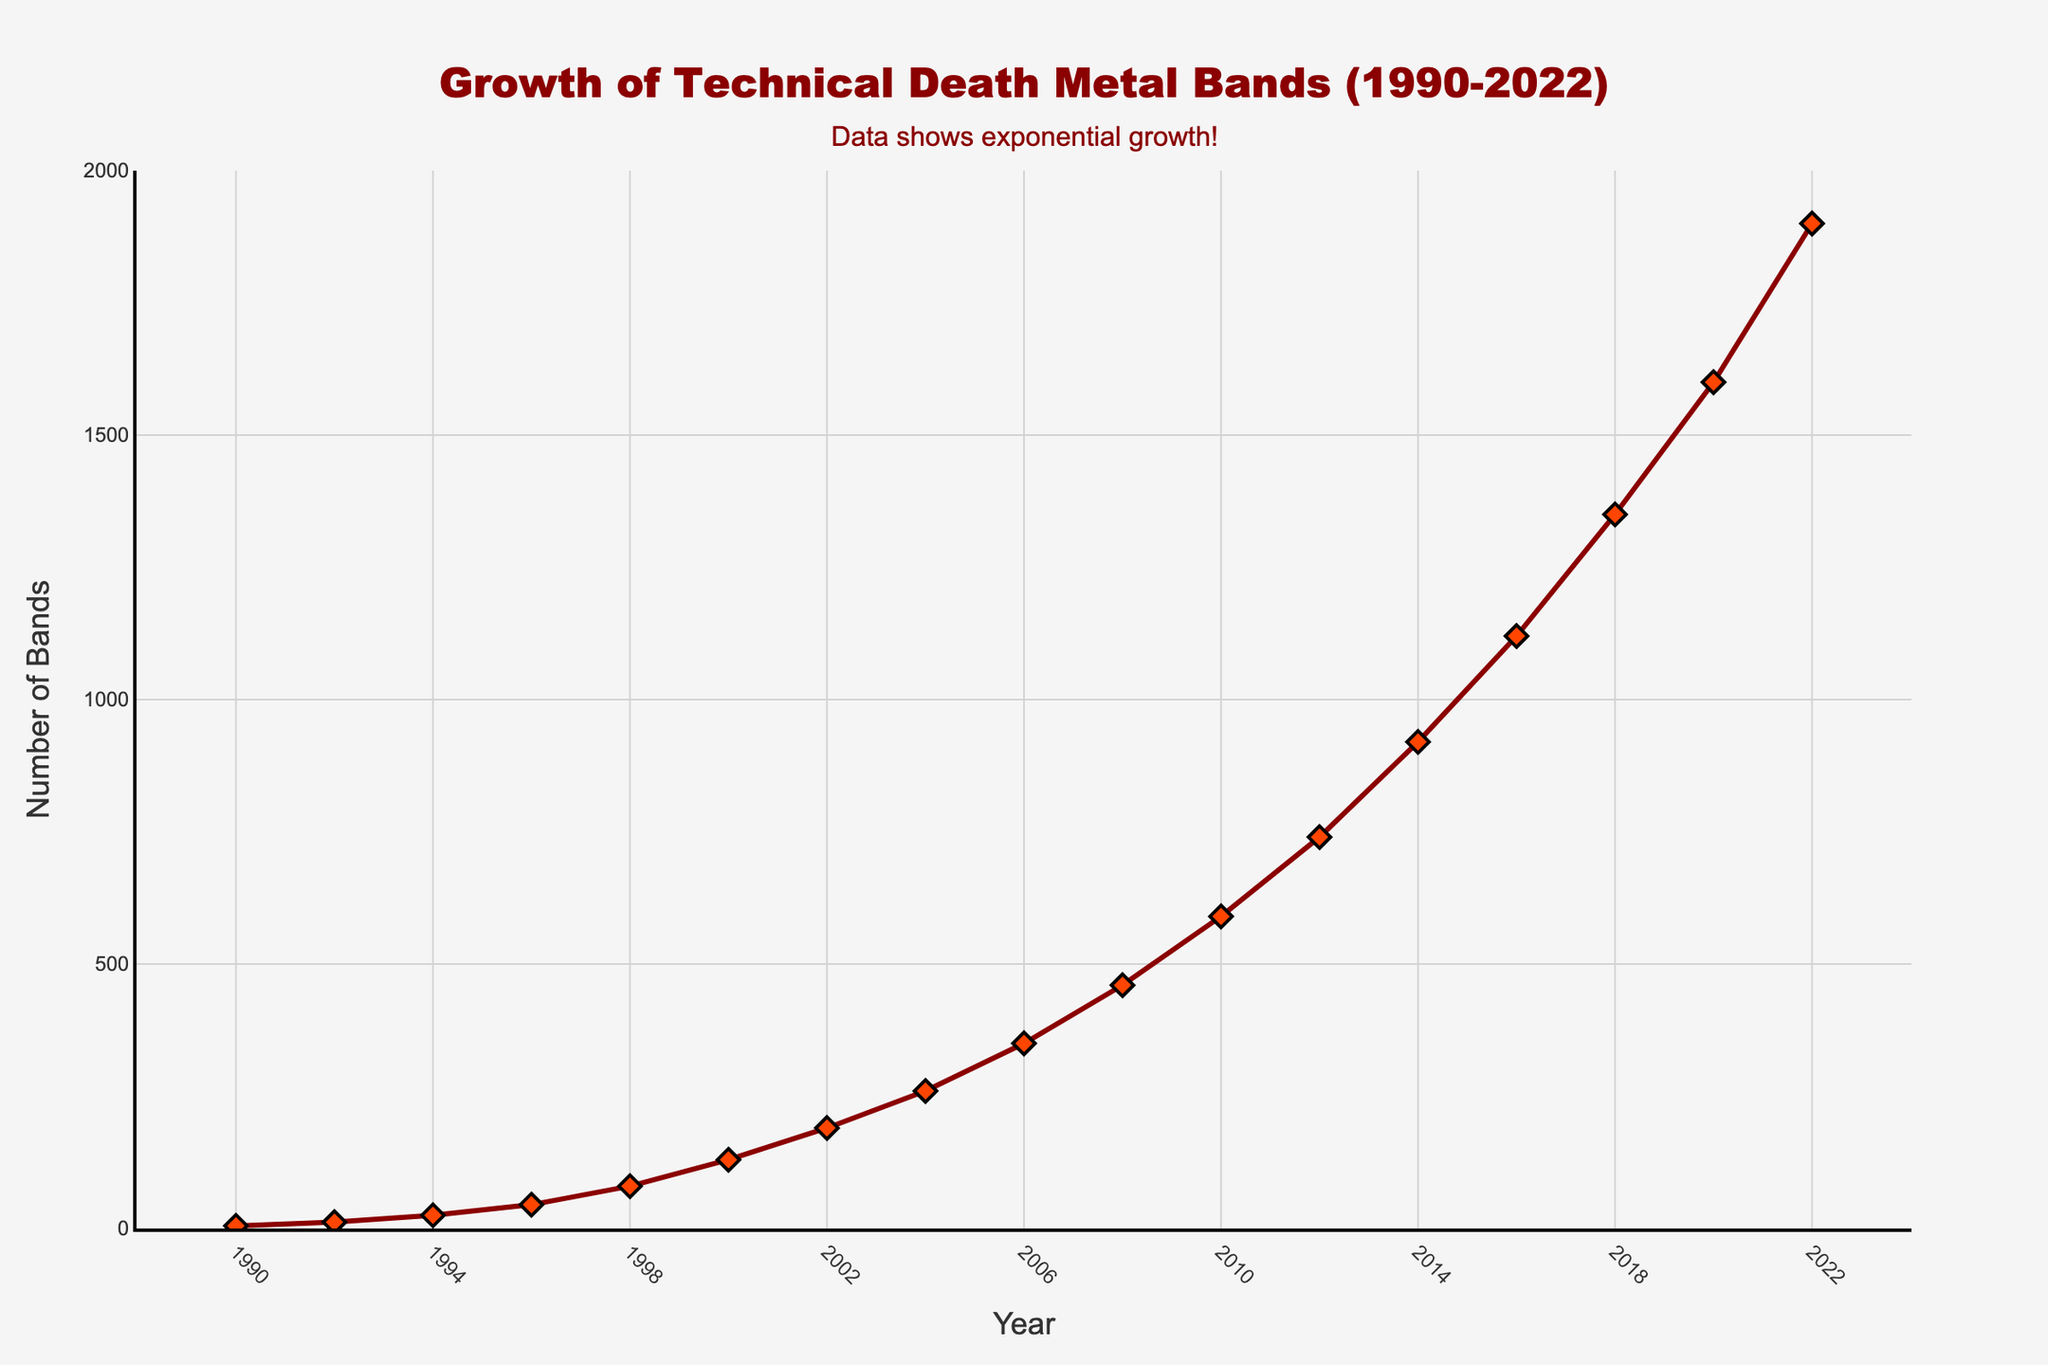What year saw the largest increase in the number of technical death metal bands from the previous data point? The largest increase occurred between 2014 and 2016, with the number of bands increasing from 920 to 1120, a difference of 200 bands.
Answer: 2016 By how many bands did the number increase from 2000 to 2010? In 2000, there were 130 bands and in 2010, there were 590 bands. The increase is 590 - 130 = 460 bands.
Answer: 460 What's the average number of bands for the years 2000, 2004, and 2008? Adding the values from the years 2000 (130), 2004 (260), and 2008 (460) gives a sum of 850. Dividing by 3 gives an average of 850 / 3 ≈ 283 bands.
Answer: 283 How many more bands were there in 2022 compared to 1990? In 1990, there were 5 bands and in 2022, there were 1900 bands. The difference is 1900 - 5 = 1895 bands.
Answer: 1895 Which year had a band count closest to 1000? The year 2016 had 1120 bands, which is the closest to 1000.
Answer: 2016 From the visual appearance, what color are the lines and the markers used in the plot? The lines are a dark red color and the markers are a bright red color with black outlines.
Answer: Dark red and bright red with black outlines What trend is noticeable in the growth of technical death metal bands from 1990 to 2022? The trend shows exponential growth, with the number of bands increasing rapidly especially after 2000.
Answer: Exponential growth Which year marks the transition from linear to exponential growth in the number of bands? The data suggests a transition around the year 2000 when the number of bands starts to increase at a faster, exponential rate.
Answer: 2000 How many times higher is the number of bands in 2022 compared to 1992? In 1992, there were 12 bands and in 2022, there were 1900 bands. The number of bands is 1900 / 12 = 158.33 times higher.
Answer: 158.33 What was the number of bands in 2002 and which increase does it denote from 1998? In 2002, there were 190 bands. From 1998's 80 bands, the increase is 190 - 80 = 110 bands.
Answer: 110 